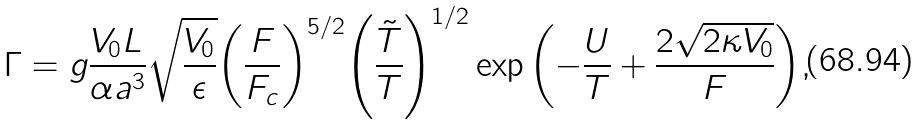Convert formula to latex. <formula><loc_0><loc_0><loc_500><loc_500>\Gamma = g \frac { V _ { 0 } L } { \alpha a ^ { 3 } } \sqrt { \frac { V _ { 0 } } { \epsilon } } { \left ( \frac { F } { F _ { c } } \right ) } ^ { { 5 } / { 2 } } { \left ( \frac { \tilde { T } } { T } \right ) } ^ { { 1 } / { 2 } } \exp { \left ( - \frac { U } { T } + \frac { 2 \sqrt { 2 \kappa V _ { 0 } } } { F } \right ) } ,</formula> 